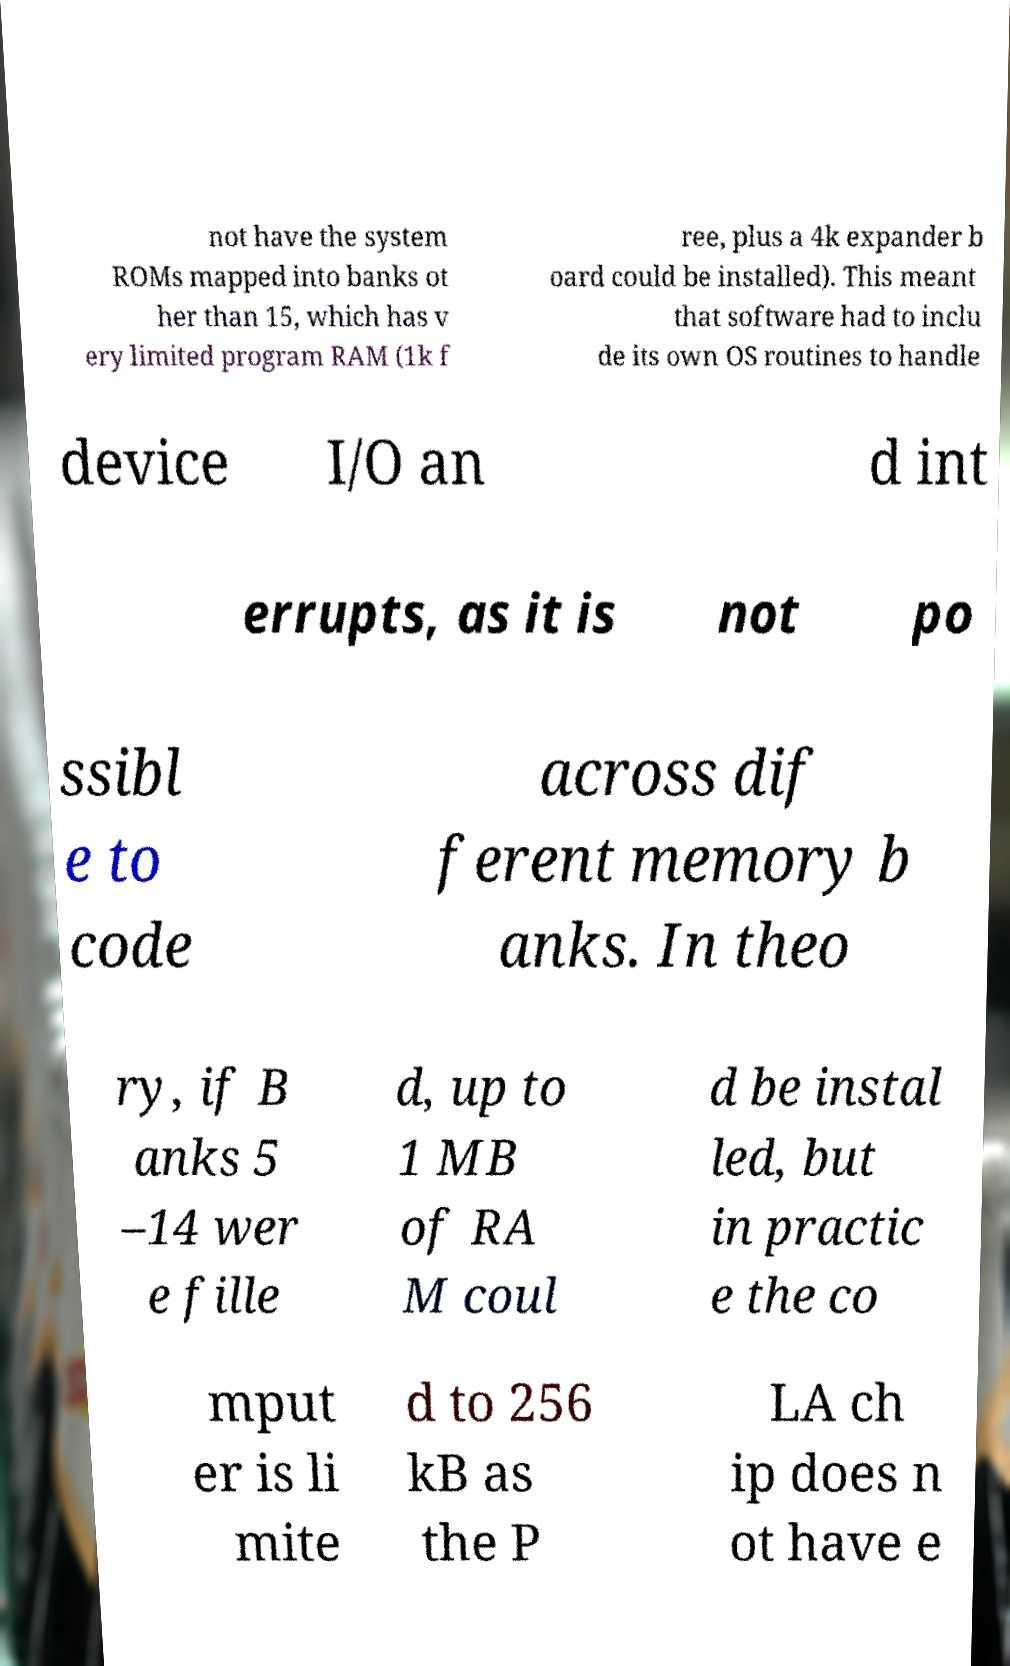Can you accurately transcribe the text from the provided image for me? not have the system ROMs mapped into banks ot her than 15, which has v ery limited program RAM (1k f ree, plus a 4k expander b oard could be installed). This meant that software had to inclu de its own OS routines to handle device I/O an d int errupts, as it is not po ssibl e to code across dif ferent memory b anks. In theo ry, if B anks 5 –14 wer e fille d, up to 1 MB of RA M coul d be instal led, but in practic e the co mput er is li mite d to 256 kB as the P LA ch ip does n ot have e 